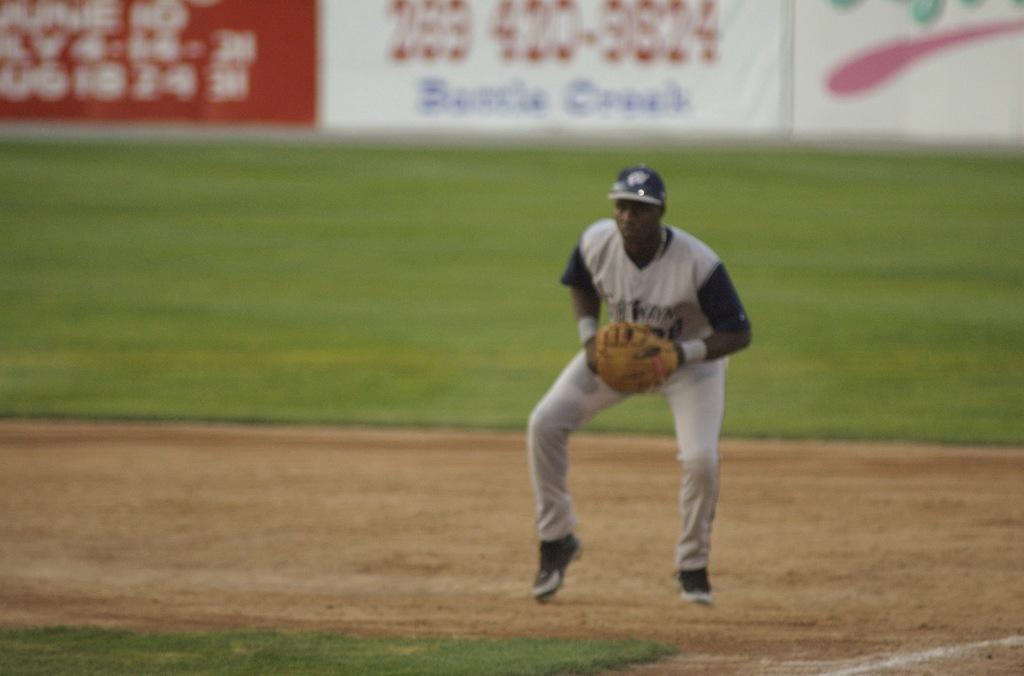Can you describe this image briefly? In this image, I can see the man standing. He wear a T-shirt, cap, trouser, shoes and gloves. This looks like a ground. In the background, I can see the hoardings. 